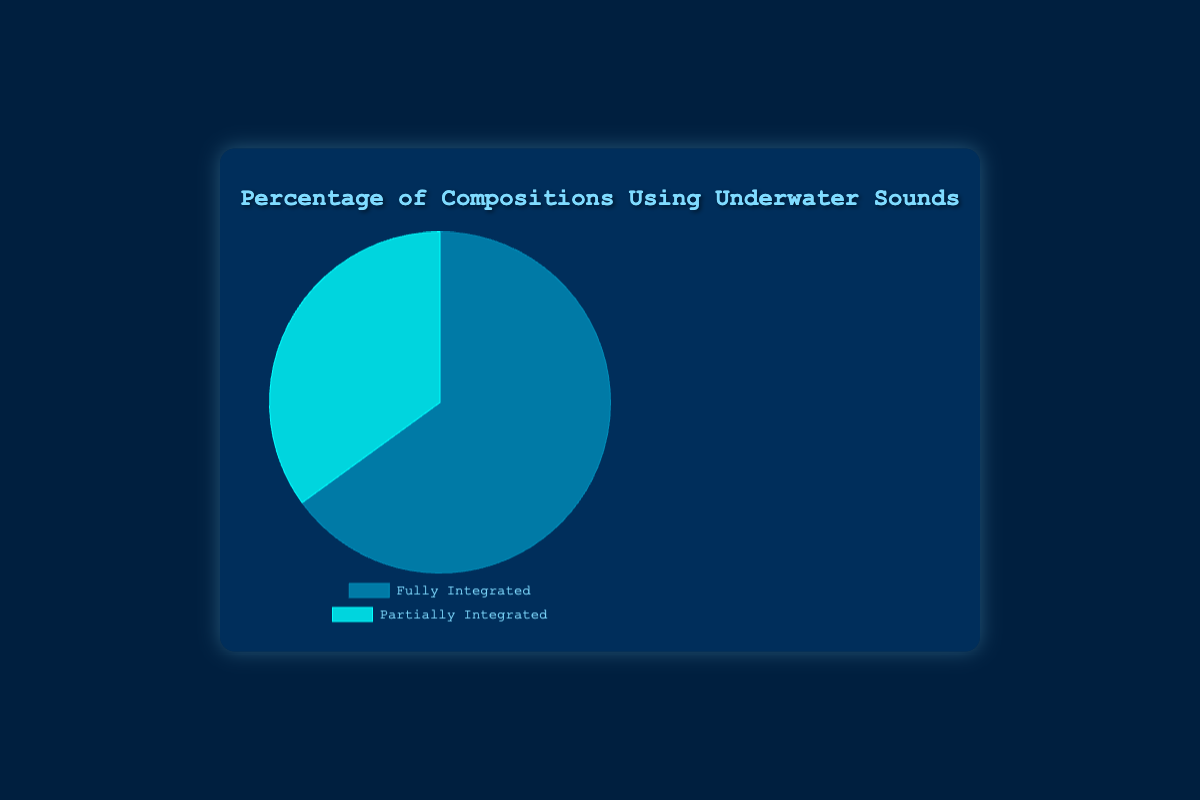What two categories are being compared in the pie chart? The pie chart compares "Fully Integrated" underwater sounds compositions and "Partially Integrated" underwater sounds compositions.
Answer: Fully Integrated and Partially Integrated Which category has the highest percentage in the pie chart? "Fully Integrated" category has the highest percentage in the pie chart, which is 65%.
Answer: Fully Integrated What is the percentage difference between Fully Integrated and Partially Integrated compositions? The percentage of Fully Integrated compositions is 65%, and for Partially Integrated, it is 35%. The difference is 65% - 35%.
Answer: 30% Together, what percentage of compositions use underwater sounds, either fully or partially? The pie chart shows two categories: Fully Integrated (65%) and Partially Integrated (35%). Adding these percentages together gives 65% + 35%.
Answer: 100% How much larger is the Fully Integrated category compared to the Partially Integrated category? Fully Integrated compositions account for 65%, and Partially Integrated for 35%. The difference (Fully Integrated - Partially Integrated) is 65% - 35%.
Answer: 30% What color represents the Fully Integrated category in the pie chart? In the pie chart, the Fully Integrated category is represented by a shade of blue.
Answer: Blue Does the Partially Integrated category cover more than half of the pie chart? The Partially Integrated category covers 35% of the pie chart, which is less than half (50%).
Answer: No If you had to split the Fully Integrated category into equal halves, what percentage would each half be? The Fully Integrated category is 65%. Splitting it into equal halves means dividing 65% by 2.
Answer: 32.5% Is the Partially Integrated category greater than a quarter of the pie chart? A quarter of the pie chart is 25%. The Partially Integrated category is 35%, which is greater than 25%.
Answer: Yes How many compositions out of 100 are not fully integrated? "Partially Integrated" compositions account for 35%. Out of 100 compositions, this is directly 35 compositions.
Answer: 35 